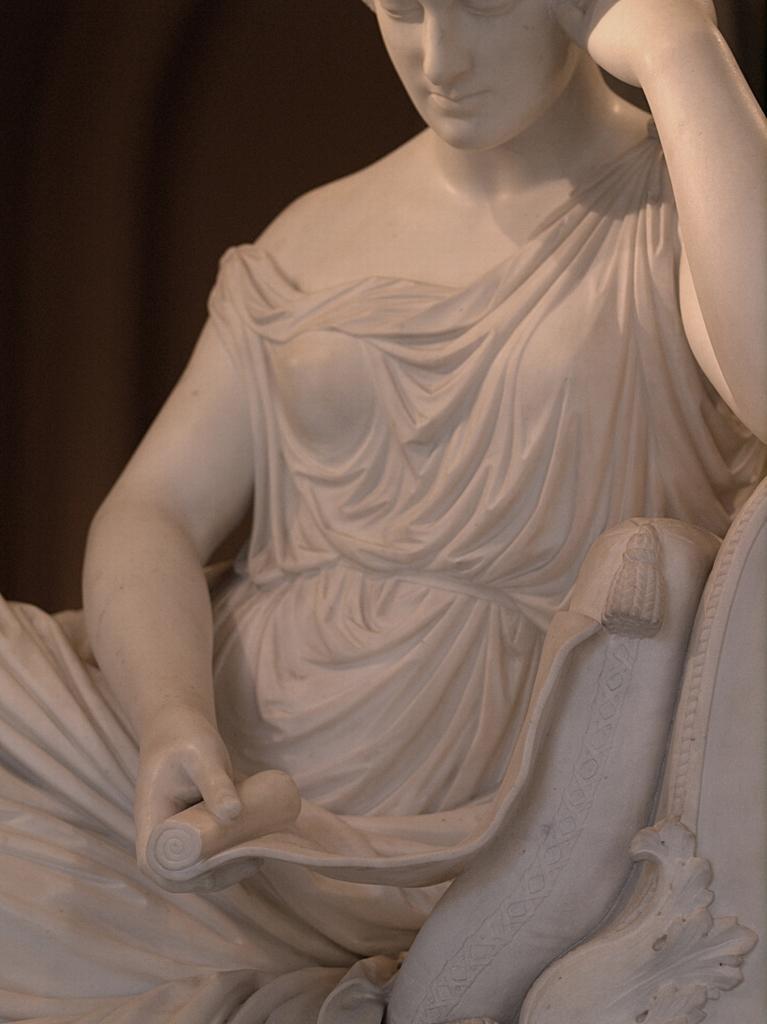Describe this image in one or two sentences. In this image we can see a sculpture of a person. A sculpture is made of a white stone. 